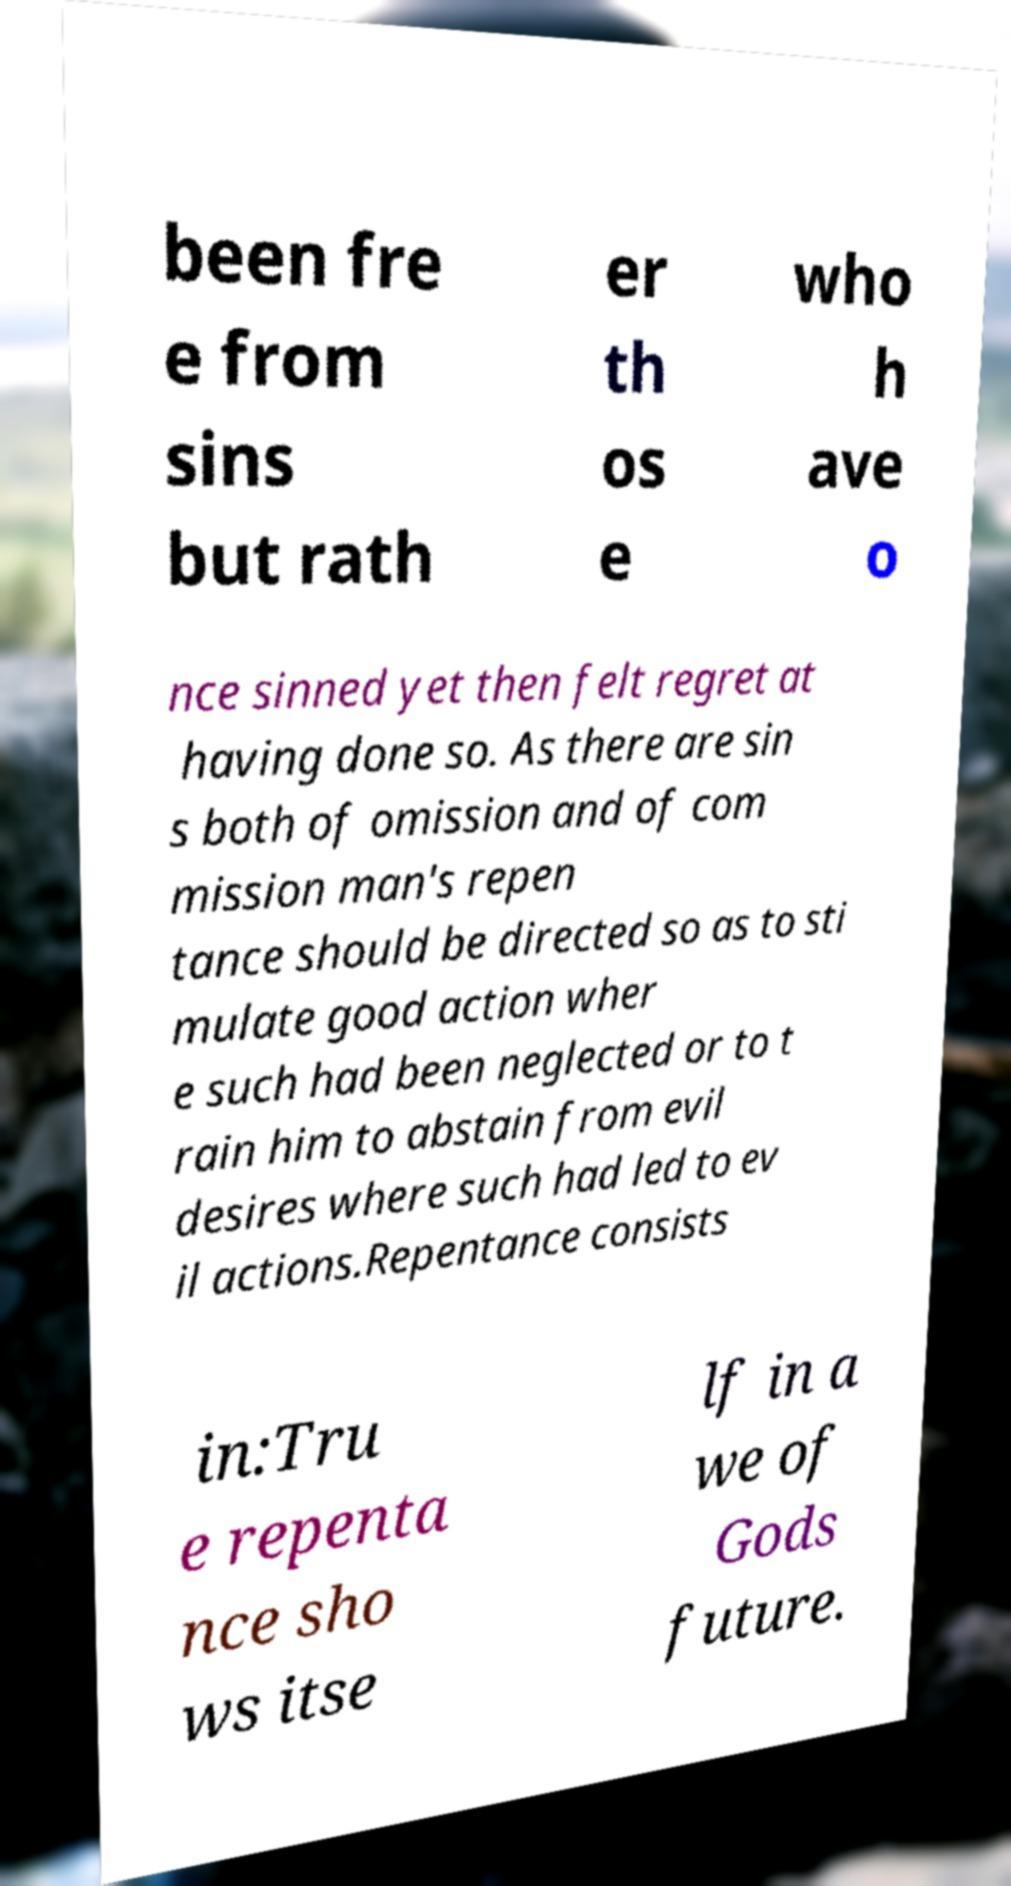Could you extract and type out the text from this image? been fre e from sins but rath er th os e who h ave o nce sinned yet then felt regret at having done so. As there are sin s both of omission and of com mission man's repen tance should be directed so as to sti mulate good action wher e such had been neglected or to t rain him to abstain from evil desires where such had led to ev il actions.Repentance consists in:Tru e repenta nce sho ws itse lf in a we of Gods future. 